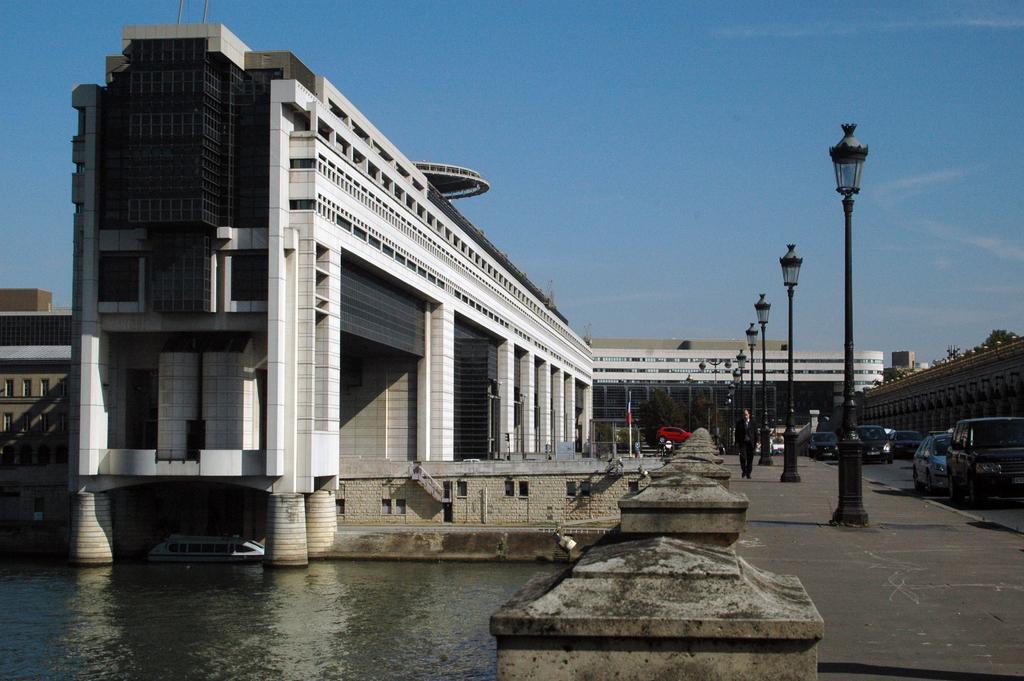In one or two sentences, can you explain what this image depicts? We can see water,lights on poles and vehicles on the road. There is a man walking. In the background we can see buildings,wall,tree and sky. 